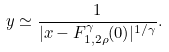<formula> <loc_0><loc_0><loc_500><loc_500>y \simeq \frac { 1 } { | x - F _ { 1 , 2 \rho } ^ { \gamma } ( 0 ) | ^ { 1 / \gamma } } .</formula> 